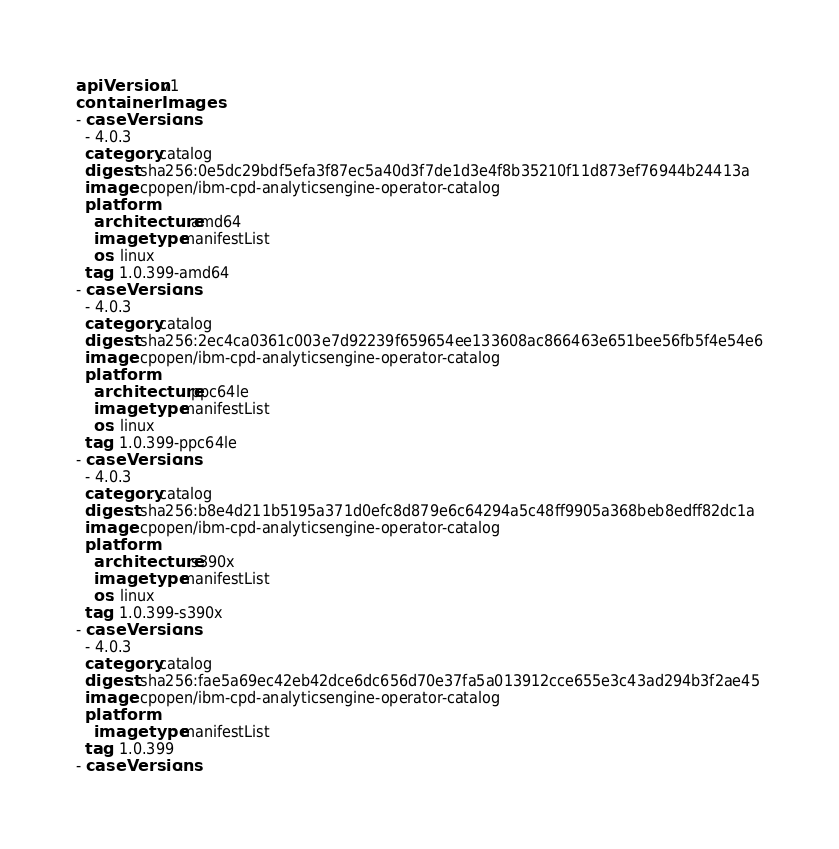Convert code to text. <code><loc_0><loc_0><loc_500><loc_500><_YAML_>apiVersion: v1
containerImages:
- caseVersions:
  - 4.0.3
  category: catalog
  digest: sha256:0e5dc29bdf5efa3f87ec5a40d3f7de1d3e4f8b35210f11d873ef76944b24413a
  image: cpopen/ibm-cpd-analyticsengine-operator-catalog
  platform:
    architecture: amd64
    imagetype: manifestList
    os: linux
  tag: 1.0.399-amd64
- caseVersions:
  - 4.0.3
  category: catalog
  digest: sha256:2ec4ca0361c003e7d92239f659654ee133608ac866463e651bee56fb5f4e54e6
  image: cpopen/ibm-cpd-analyticsengine-operator-catalog
  platform:
    architecture: ppc64le
    imagetype: manifestList
    os: linux
  tag: 1.0.399-ppc64le
- caseVersions:
  - 4.0.3
  category: catalog
  digest: sha256:b8e4d211b5195a371d0efc8d879e6c64294a5c48ff9905a368beb8edff82dc1a
  image: cpopen/ibm-cpd-analyticsengine-operator-catalog
  platform:
    architecture: s390x
    imagetype: manifestList
    os: linux
  tag: 1.0.399-s390x
- caseVersions:
  - 4.0.3
  category: catalog
  digest: sha256:fae5a69ec42eb42dce6dc656d70e37fa5a013912cce655e3c43ad294b3f2ae45
  image: cpopen/ibm-cpd-analyticsengine-operator-catalog
  platform:
    imagetype: manifestList
  tag: 1.0.399
- caseVersions:</code> 